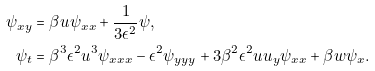Convert formula to latex. <formula><loc_0><loc_0><loc_500><loc_500>\psi _ { x y } & = \beta u \psi _ { x x } + \frac { 1 } { 3 \epsilon ^ { 2 } } \psi , \\ \psi _ { t } & = \beta ^ { 3 } \epsilon ^ { 2 } u ^ { 3 } \psi _ { x x x } - \epsilon ^ { 2 } \psi _ { y y y } + 3 \beta ^ { 2 } \epsilon ^ { 2 } u u _ { y } \psi _ { x x } + \beta w \psi _ { x } .</formula> 